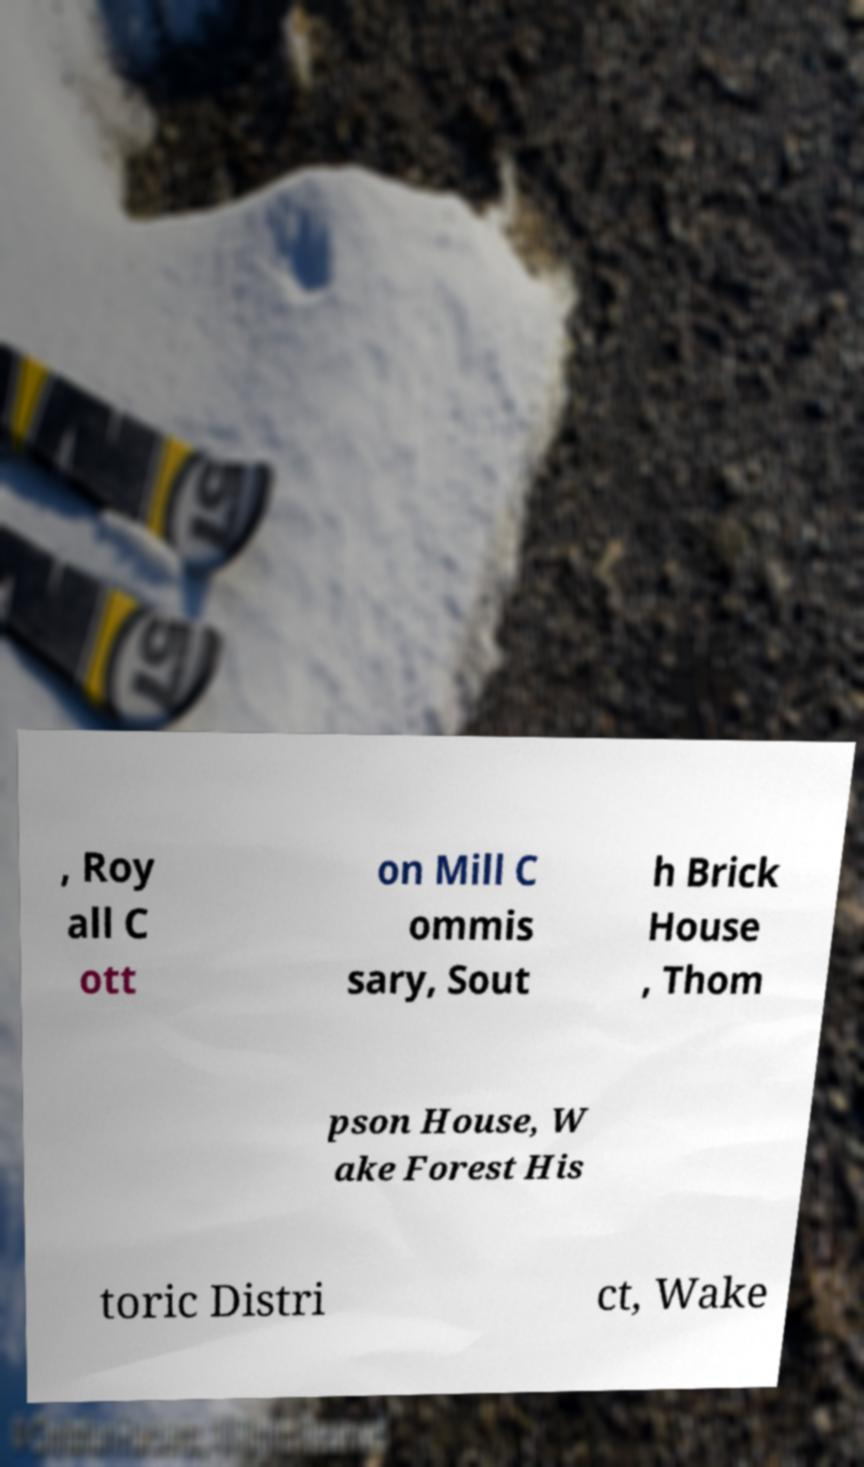Can you accurately transcribe the text from the provided image for me? , Roy all C ott on Mill C ommis sary, Sout h Brick House , Thom pson House, W ake Forest His toric Distri ct, Wake 